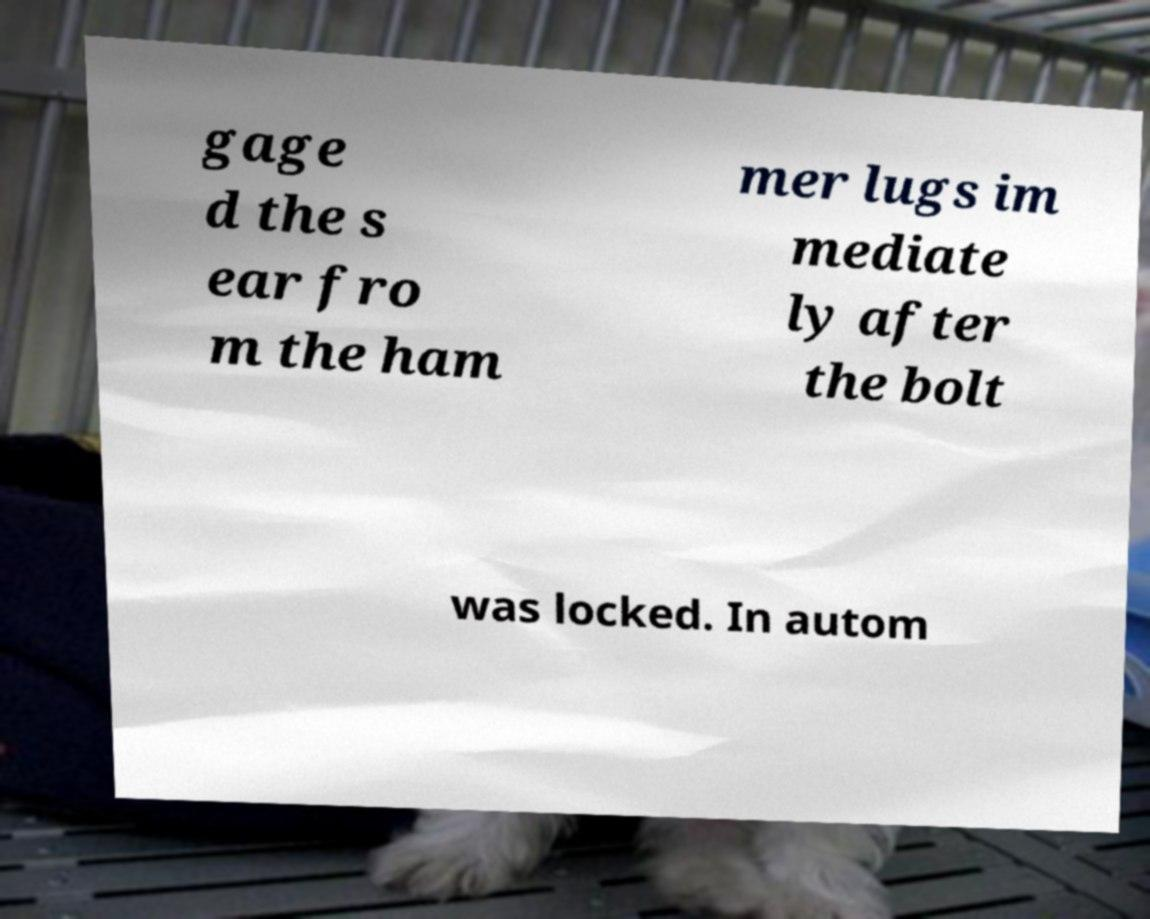I need the written content from this picture converted into text. Can you do that? gage d the s ear fro m the ham mer lugs im mediate ly after the bolt was locked. In autom 